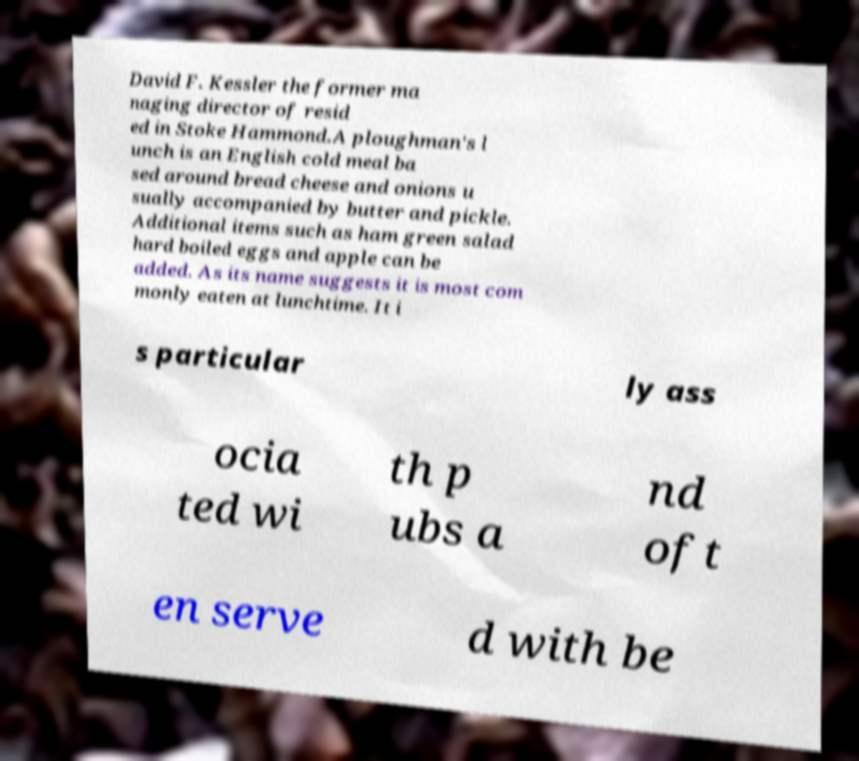Please read and relay the text visible in this image. What does it say? David F. Kessler the former ma naging director of resid ed in Stoke Hammond.A ploughman's l unch is an English cold meal ba sed around bread cheese and onions u sually accompanied by butter and pickle. Additional items such as ham green salad hard boiled eggs and apple can be added. As its name suggests it is most com monly eaten at lunchtime. It i s particular ly ass ocia ted wi th p ubs a nd oft en serve d with be 